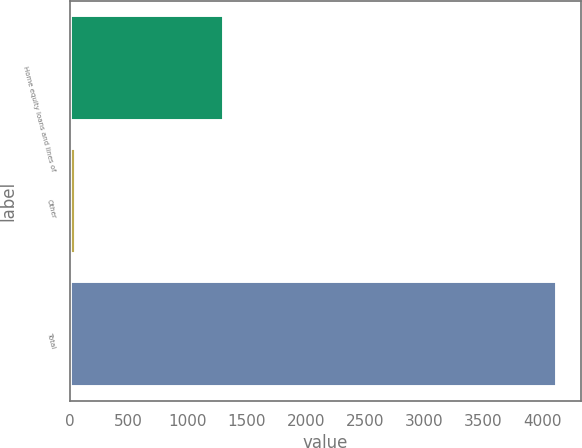Convert chart. <chart><loc_0><loc_0><loc_500><loc_500><bar_chart><fcel>Home equity loans and lines of<fcel>Other<fcel>Total<nl><fcel>1307<fcel>52<fcel>4125<nl></chart> 